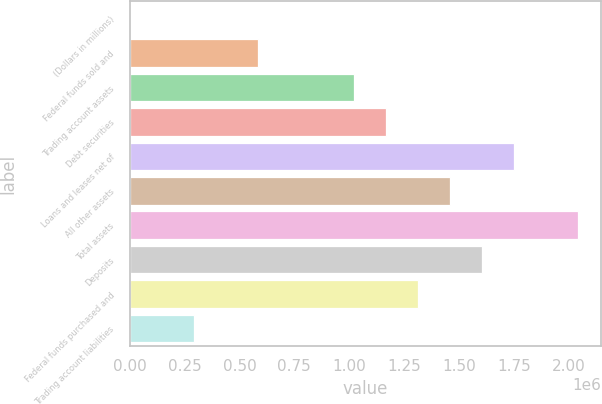Convert chart to OTSL. <chart><loc_0><loc_0><loc_500><loc_500><bar_chart><fcel>(Dollars in millions)<fcel>Federal funds sold and<fcel>Trading account assets<fcel>Debt securities<fcel>Loans and leases net of<fcel>All other assets<fcel>Total assets<fcel>Deposits<fcel>Federal funds purchased and<fcel>Trading account liabilities<nl><fcel>2006<fcel>585098<fcel>1.02242e+06<fcel>1.16819e+06<fcel>1.75128e+06<fcel>1.45974e+06<fcel>2.04283e+06<fcel>1.60551e+06<fcel>1.31396e+06<fcel>293552<nl></chart> 